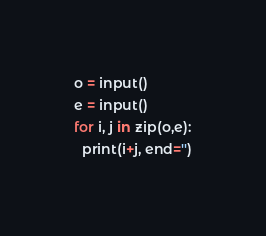Convert code to text. <code><loc_0><loc_0><loc_500><loc_500><_Python_>o = input()
e = input()
for i, j in zip(o,e):
  print(i+j, end='')</code> 